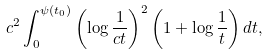Convert formula to latex. <formula><loc_0><loc_0><loc_500><loc_500>c ^ { 2 } \int _ { 0 } ^ { \psi ( t _ { 0 } ) } \left ( \log \frac { 1 } { c t } \right ) ^ { 2 } \left ( 1 + \log \frac { 1 } { t } \right ) d t ,</formula> 